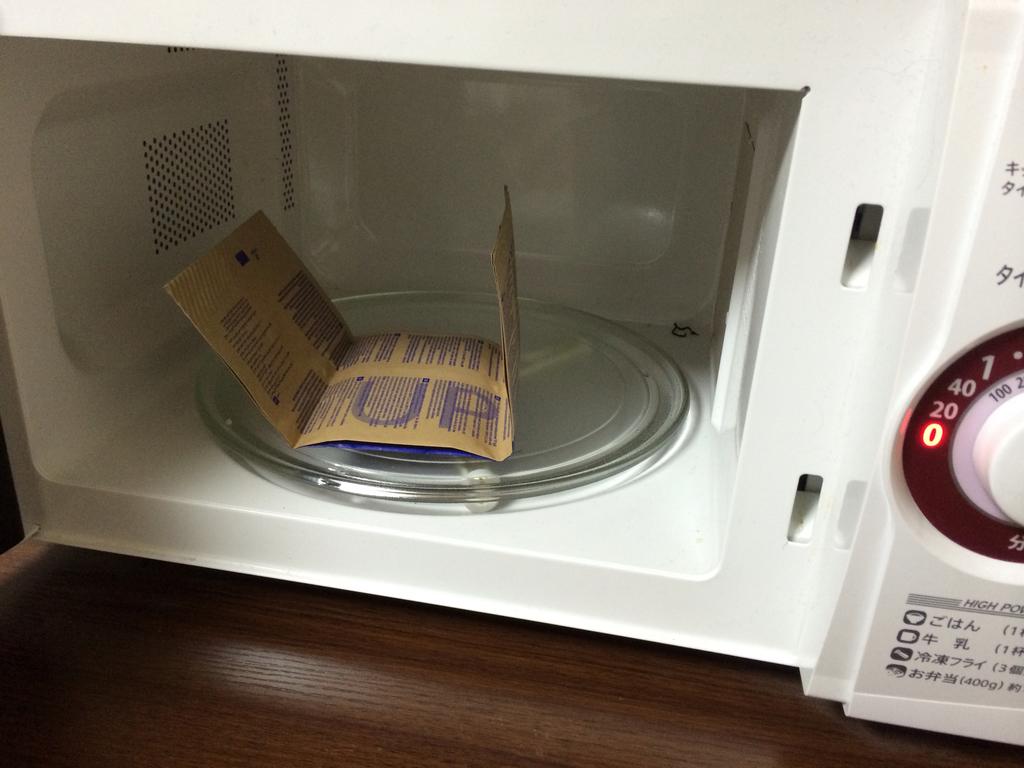What is written in big print on the bag?
Provide a short and direct response. Up. 